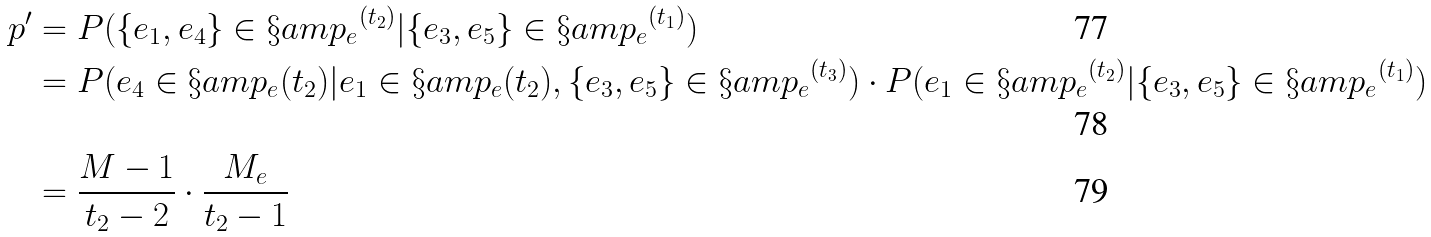<formula> <loc_0><loc_0><loc_500><loc_500>p ^ { \prime } & = P ( \{ e _ { 1 } , e _ { 4 } \} \in { \S a m p _ { e } } ^ { ( t _ { 2 } ) } | \{ e _ { 3 } , e _ { 5 } \} \in { \S a m p _ { e } } ^ { ( t _ { 1 } ) } ) \\ & = P ( e _ { 4 } \in \S a m p _ { e } ( t _ { 2 } ) | e _ { 1 } \in \S a m p _ { e } ( t _ { 2 } ) , \{ e _ { 3 } , e _ { 5 } \} \in { \S a m p _ { e } } ^ { ( t _ { 3 } ) } ) \cdot P ( e _ { 1 } \in { \S a m p _ { e } } ^ { ( t _ { 2 } ) } | \{ e _ { 3 } , e _ { 5 } \} \in { \S a m p _ { e } } ^ { ( t _ { 1 } ) } ) \\ & = \frac { M - 1 } { t _ { 2 } - 2 } \cdot \frac { M _ { e } } { t _ { 2 } - 1 }</formula> 